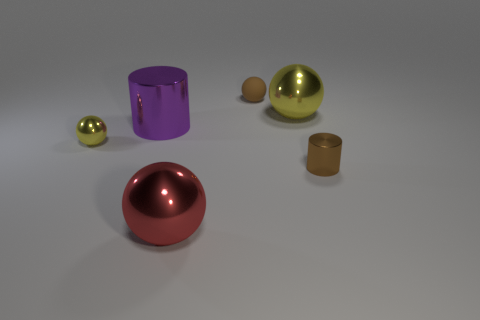Do the cylinder behind the brown metallic cylinder and the rubber ball have the same size?
Provide a short and direct response. No. What number of blocks are small matte objects or large purple things?
Your answer should be very brief. 0. There is a tiny object on the left side of the tiny brown rubber object; what is it made of?
Provide a succinct answer. Metal. Is the number of tiny spheres less than the number of things?
Provide a succinct answer. Yes. What size is the metal sphere that is right of the large purple metallic cylinder and behind the red thing?
Your response must be concise. Large. How big is the cylinder to the left of the big metallic sphere that is in front of the yellow metal object that is to the right of the big cylinder?
Keep it short and to the point. Large. What number of other objects are the same color as the tiny metal ball?
Make the answer very short. 1. Does the metallic thing that is in front of the small brown cylinder have the same color as the rubber ball?
Keep it short and to the point. No. What number of objects are either red metallic spheres or tiny brown shiny things?
Give a very brief answer. 2. There is a large ball in front of the tiny metallic cylinder; what is its color?
Offer a terse response. Red. 